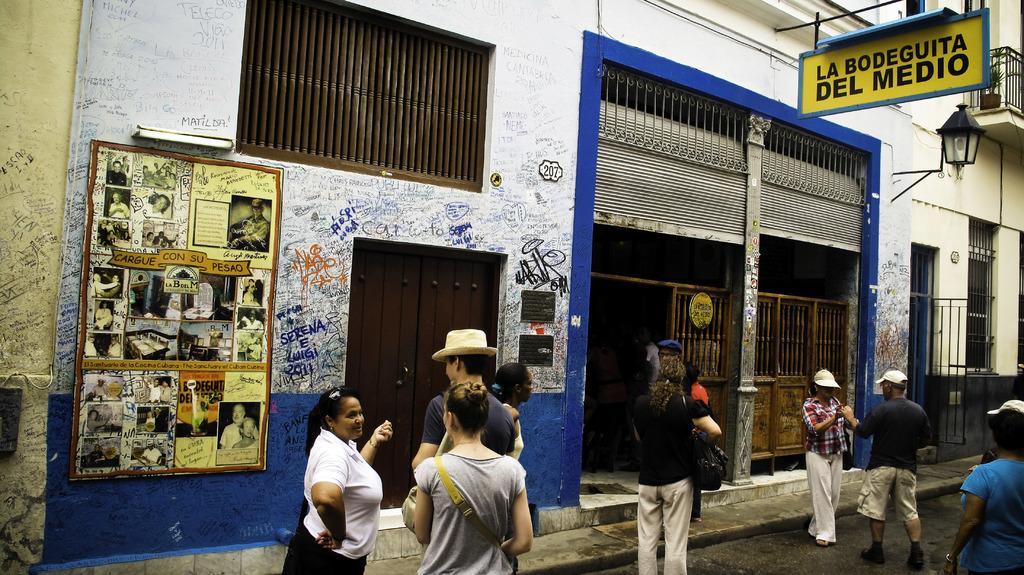Can you describe this image briefly? This is an outside view. At the bottom there are few people standing on the road. Here I can see a building. On the left side there is a poster attached to the wall. On the poster, I can see few images of persons. On the wall, I can see the text. On the right side there is a shutter. In the top right there is a board on which I can see some text. 